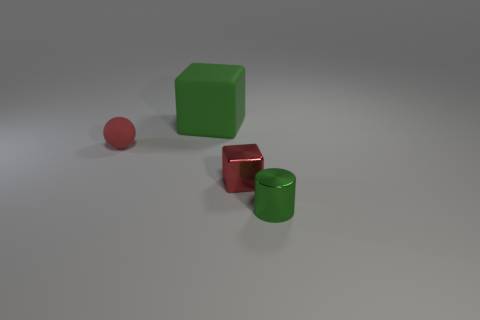Add 2 big brown rubber things. How many objects exist? 6 Subtract all cylinders. How many objects are left? 3 Subtract all large red shiny cubes. Subtract all tiny red balls. How many objects are left? 3 Add 3 red matte balls. How many red matte balls are left? 4 Add 2 big purple things. How many big purple things exist? 2 Subtract 0 yellow cylinders. How many objects are left? 4 